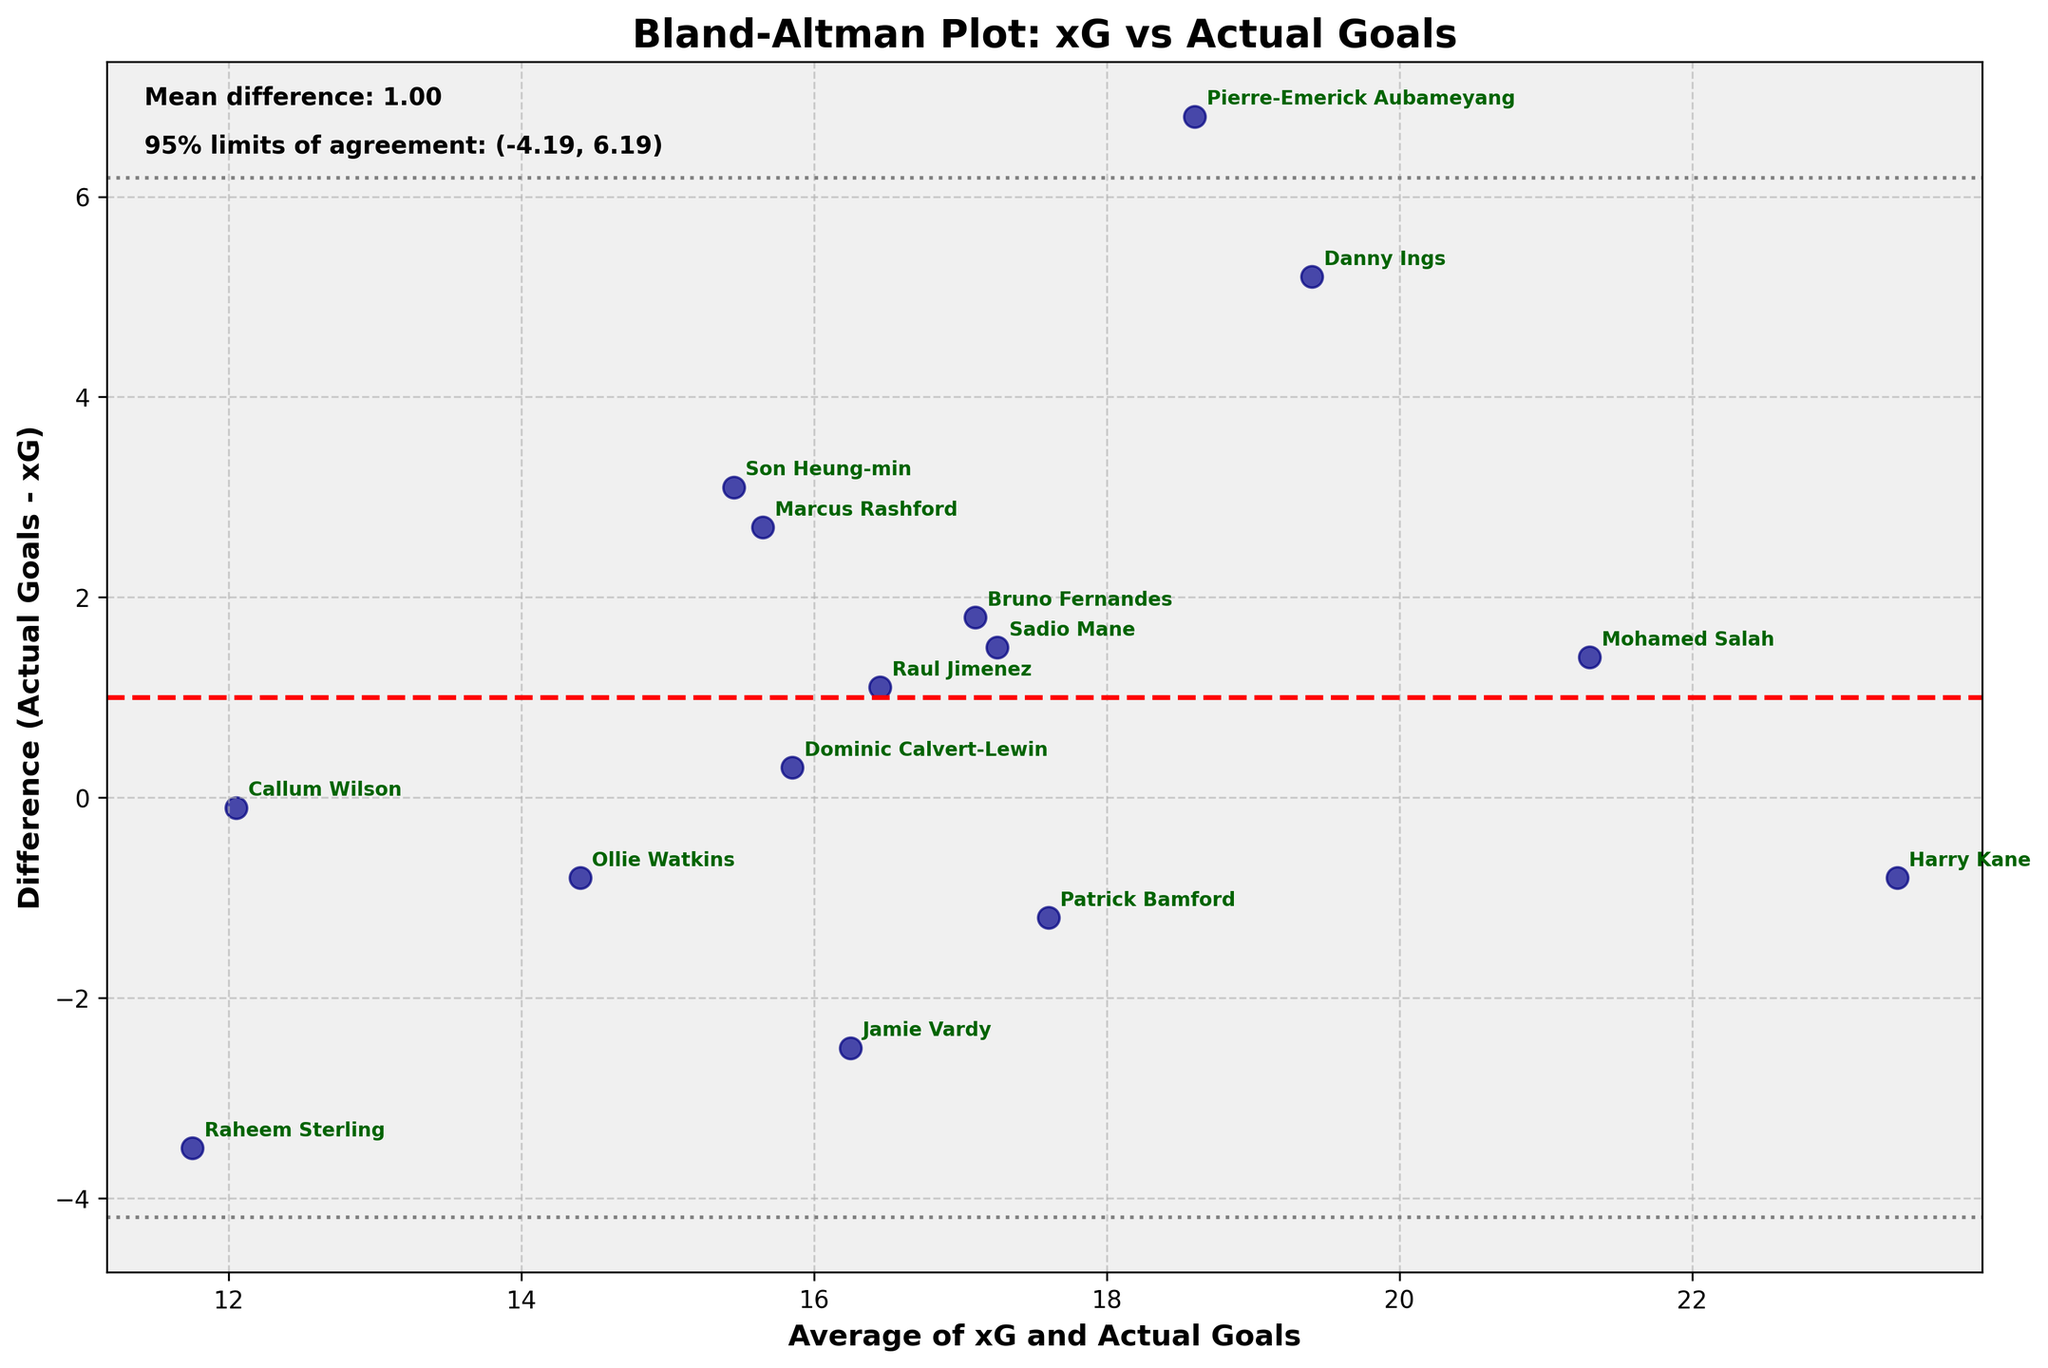What's the title of the plot? The title of the plot is located at the top and usually provides a summary of what the plot represents. In this case, the title reads "Bland-Altman Plot: xG vs Actual Goals".
Answer: Bland-Altman Plot: xG vs Actual Goals How many data points are included in the plot? By counting the number of individual points scattered in the plot, we can determine the total number of data points. There are 15 data points in this plot.
Answer: 15 Which player’s actual goals exceed their xG by the largest margin? To find this, look for the maximum y-value (Difference) where the plot has annotations. According to the data, Pierre-Emerick Aubameyang has the largest positive difference of 6.8.
Answer: Pierre-Emerick Aubameyang What is the average of xG and actual goals for Harry Kane? Look at the data point annotated with "Harry Kane" and refer to the x-axis value for the average. It is 23.4.
Answer: 23.4 What's the mean difference between actual goals and expected goals (xG) across all players? The mean difference is represented by the red dashed line. The plot has a text annotation that reads "Mean difference: 1.23".
Answer: 1.23 Which player has actual goals significantly lower than their xG? Refer to the points on the plot to identify the player with the most negative difference. The point for Raheem Sterling has the largest negative difference of -3.5.
Answer: Raheem Sterling What is the range of the 95% limits of agreement? This can be identified by looking at the text annotations on the plot. The annotation reads "95% limits of agreement: (-3.02, 5.49)".
Answer: (-3.02, 5.49) How many players scored above their xG according to the plot? Count the number of data points that are above the zero line (y > 0). In this plot, 9 players have positive differences, meaning they scored more than their xG.
Answer: 9 Which player has an average (xG and actual goals) closest to 16? Look for the data point closest to 16 on the x-axis. Jamie Vardy is closest with an average of 16.25.
Answer: Jamie Vardy How does the actual goals of Marcus Rashford compare with his xG? Find Marcus Rashford's annotation on the plot and check the corresponding y-value (Difference). Marcus Rashford has a difference of 2.7, meaning he scored 2.7 goals more than his xG.
Answer: 2.7 more 